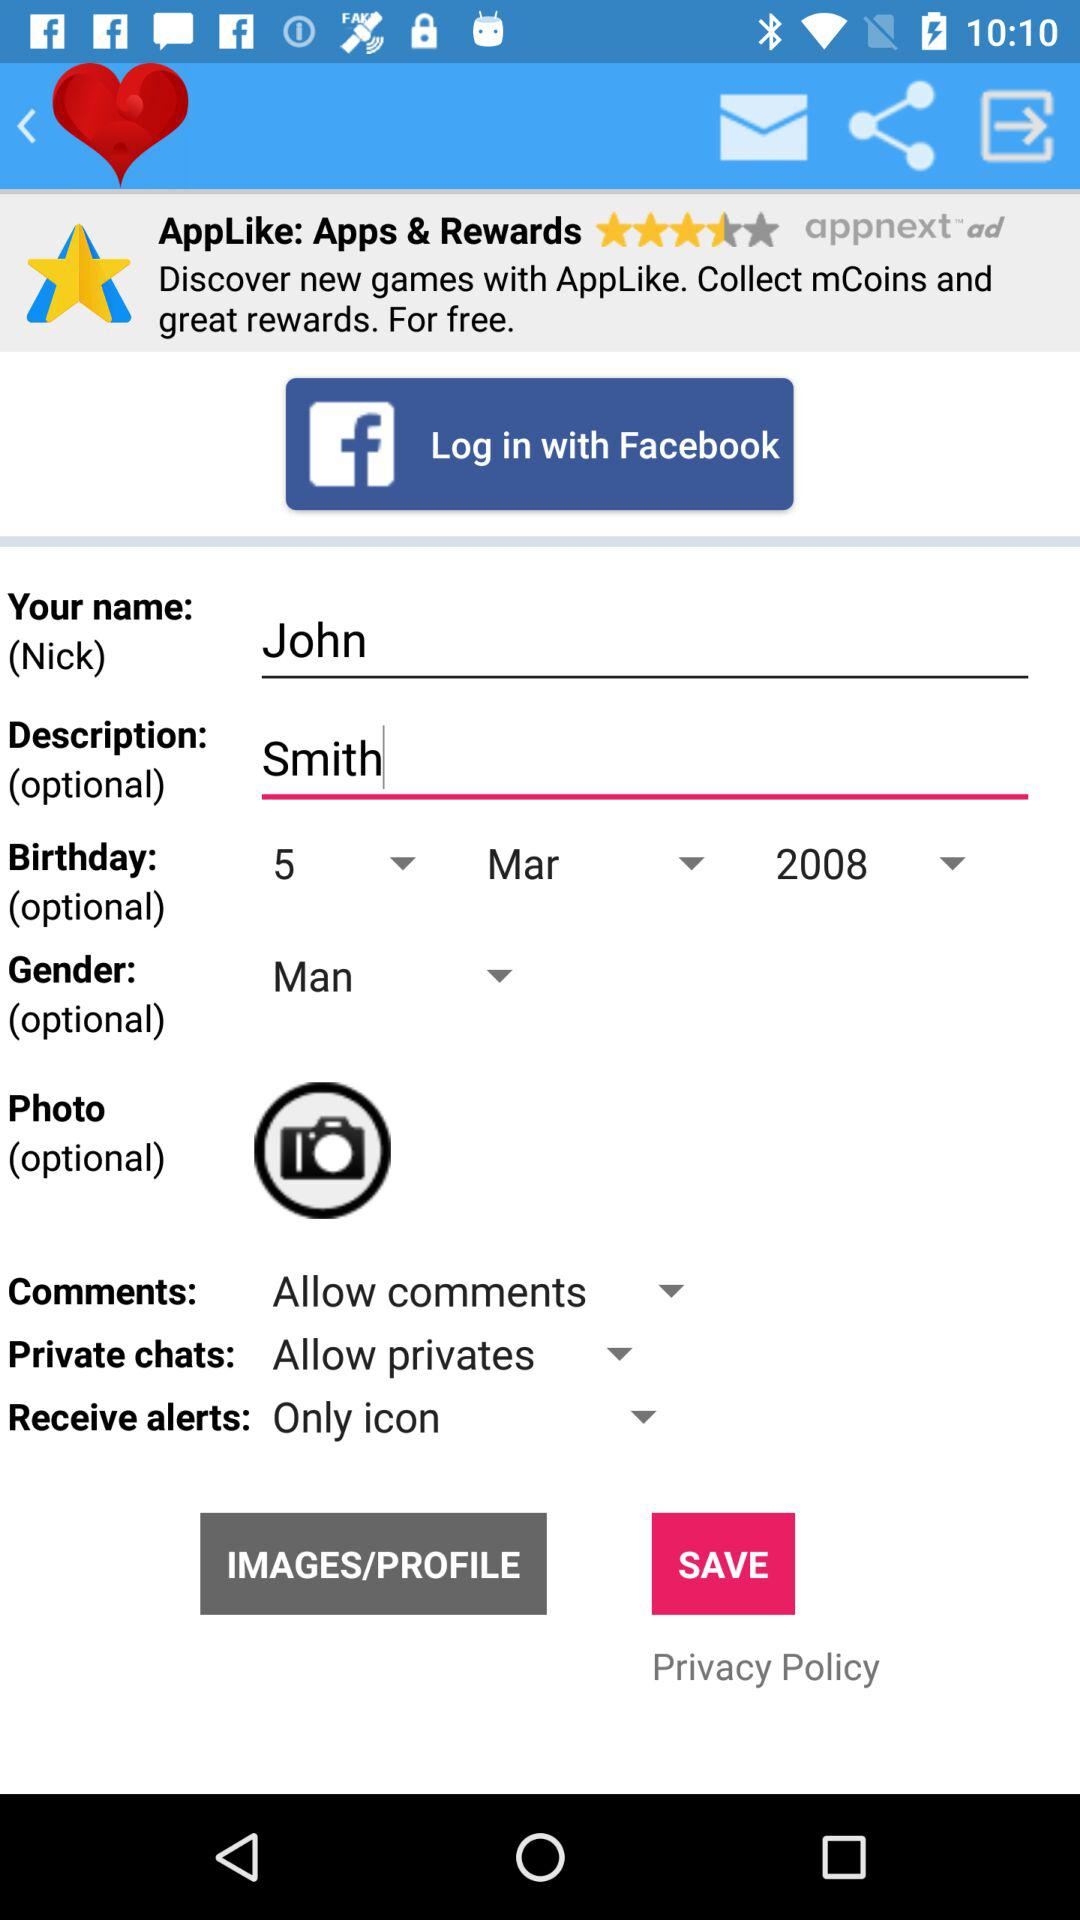What option is selected for comments? The selected option for comments is "Allow comments". 